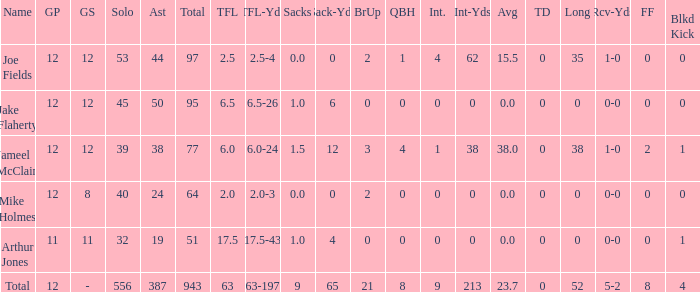What is the largest number of tds scored for a player? 0.0. 